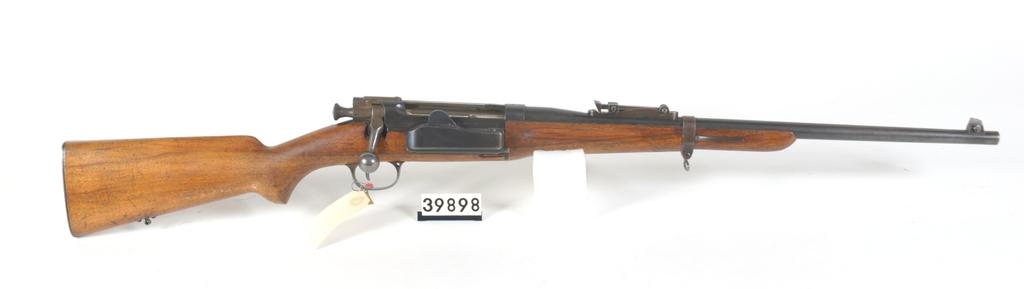What is the main object in the image? There is a rifle in the image. What else can be seen in the image besides the rifle? There is a board in the image. What color is the background of the image? The background of the image is white. What type of weather can be seen in the image? There is no weather depicted in the image, as it is a still image with a white background. What kind of pet is present in the image? There are no pets present in the image; it features a rifle and a board. 